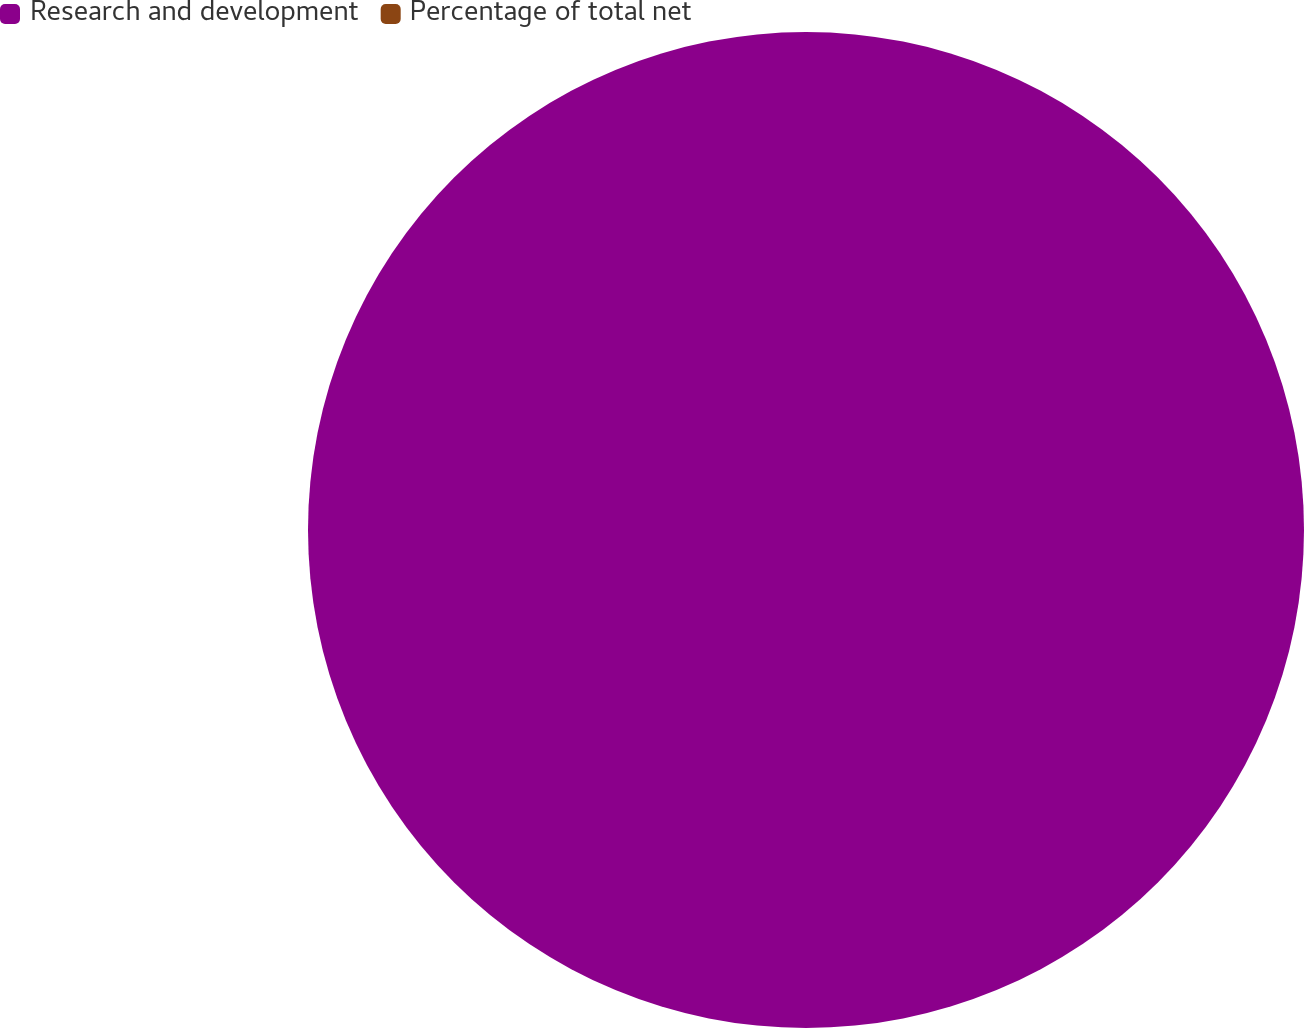Convert chart to OTSL. <chart><loc_0><loc_0><loc_500><loc_500><pie_chart><fcel>Research and development<fcel>Percentage of total net<nl><fcel>100.0%<fcel>0.0%<nl></chart> 